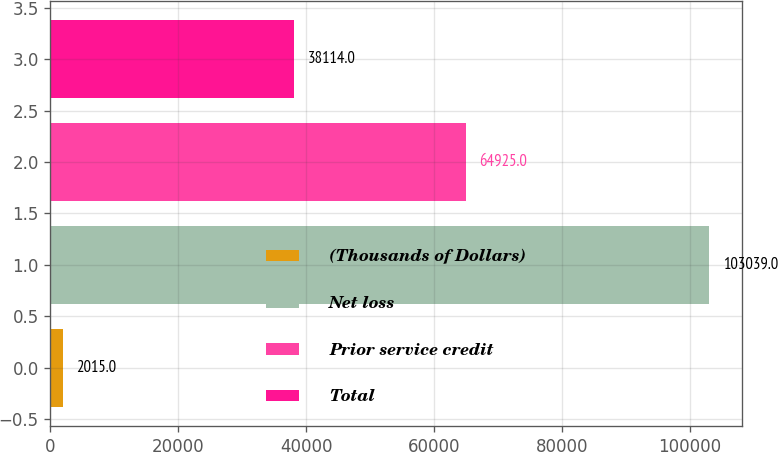Convert chart. <chart><loc_0><loc_0><loc_500><loc_500><bar_chart><fcel>(Thousands of Dollars)<fcel>Net loss<fcel>Prior service credit<fcel>Total<nl><fcel>2015<fcel>103039<fcel>64925<fcel>38114<nl></chart> 